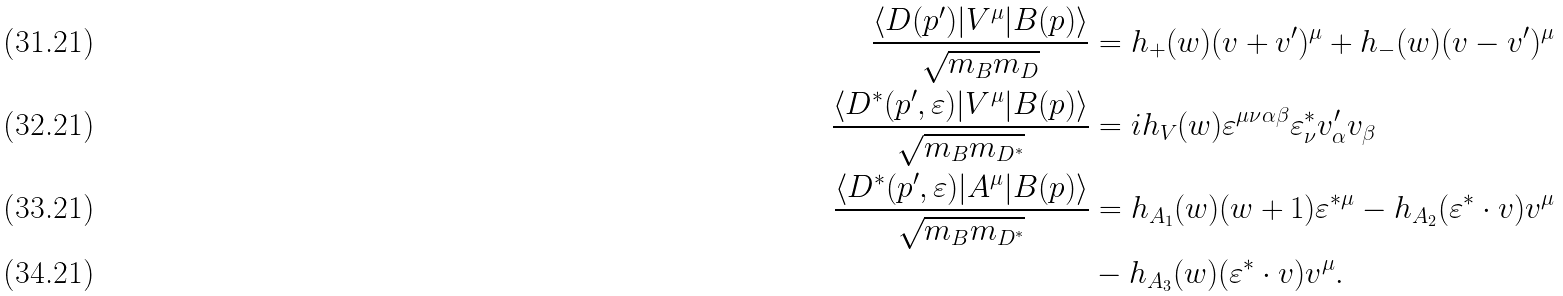<formula> <loc_0><loc_0><loc_500><loc_500>\frac { \langle D ( p ^ { \prime } ) | V ^ { \mu } | B ( p ) \rangle } { \sqrt { m _ { B } m _ { D } } } & = h _ { + } ( w ) ( v + v ^ { \prime } ) ^ { \mu } + h _ { - } ( w ) ( v - v ^ { \prime } ) ^ { \mu } \\ \frac { \langle D ^ { * } ( p ^ { \prime } , \varepsilon ) | V ^ { \mu } | B ( p ) \rangle } { \sqrt { m _ { B } m _ { D ^ { * } } } } & = i h _ { V } ( w ) \varepsilon ^ { \mu \nu \alpha \beta } \varepsilon _ { \nu } ^ { * } v _ { \alpha } ^ { \prime } v _ { \beta } \\ \frac { \langle D ^ { * } ( p ^ { \prime } , \varepsilon ) | A ^ { \mu } | B ( p ) \rangle } { \sqrt { m _ { B } m _ { D ^ { * } } } } & = h _ { A _ { 1 } } ( w ) ( w + 1 ) \varepsilon ^ { * \mu } - h _ { A _ { 2 } } ( \varepsilon ^ { * } \cdot v ) v ^ { \mu } \\ & - h _ { A _ { 3 } } ( w ) ( \varepsilon ^ { * } \cdot v ) v ^ { \mu } .</formula> 